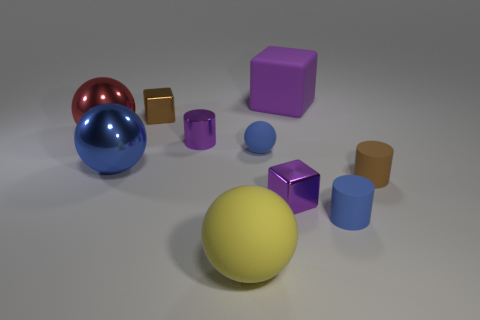Is the color of the metal cube on the right side of the purple metal cylinder the same as the big rubber block?
Give a very brief answer. Yes. There is a tiny rubber object that is the same shape as the red metal object; what color is it?
Your answer should be compact. Blue. How many tiny things are either cyan metallic cylinders or red shiny balls?
Give a very brief answer. 0. There is a shiny cube behind the red sphere; what is its size?
Provide a succinct answer. Small. Are there any rubber cylinders that have the same color as the small ball?
Your answer should be compact. Yes. Is the large rubber cube the same color as the tiny rubber ball?
Your response must be concise. No. There is a small rubber object that is the same color as the tiny sphere; what is its shape?
Your response must be concise. Cylinder. How many small cubes are in front of the tiny cylinder that is on the left side of the big purple matte thing?
Provide a succinct answer. 1. How many brown cylinders have the same material as the big blue sphere?
Your answer should be compact. 0. There is a tiny blue sphere; are there any tiny blue rubber balls in front of it?
Keep it short and to the point. No. 